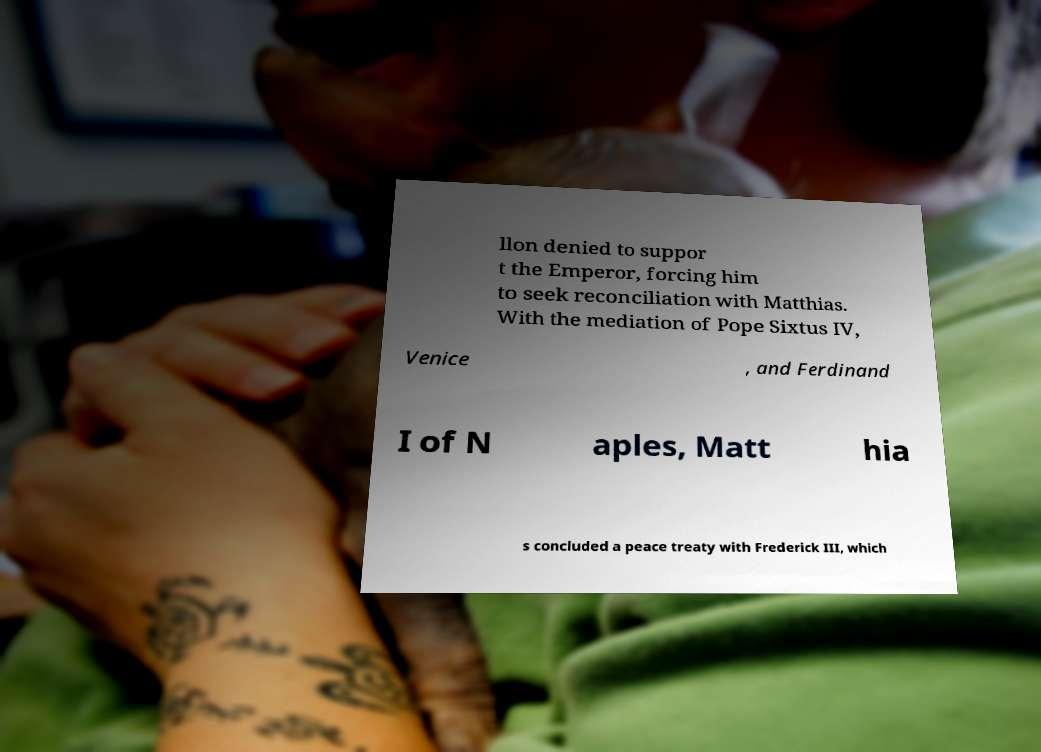I need the written content from this picture converted into text. Can you do that? llon denied to suppor t the Emperor, forcing him to seek reconciliation with Matthias. With the mediation of Pope Sixtus IV, Venice , and Ferdinand I of N aples, Matt hia s concluded a peace treaty with Frederick III, which 